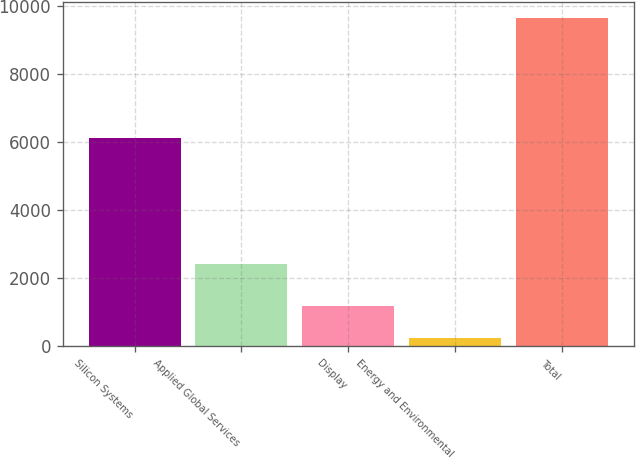<chart> <loc_0><loc_0><loc_500><loc_500><bar_chart><fcel>Silicon Systems<fcel>Applied Global Services<fcel>Display<fcel>Energy and Environmental<fcel>Total<nl><fcel>6132<fcel>2433<fcel>1179<fcel>238<fcel>9648<nl></chart> 